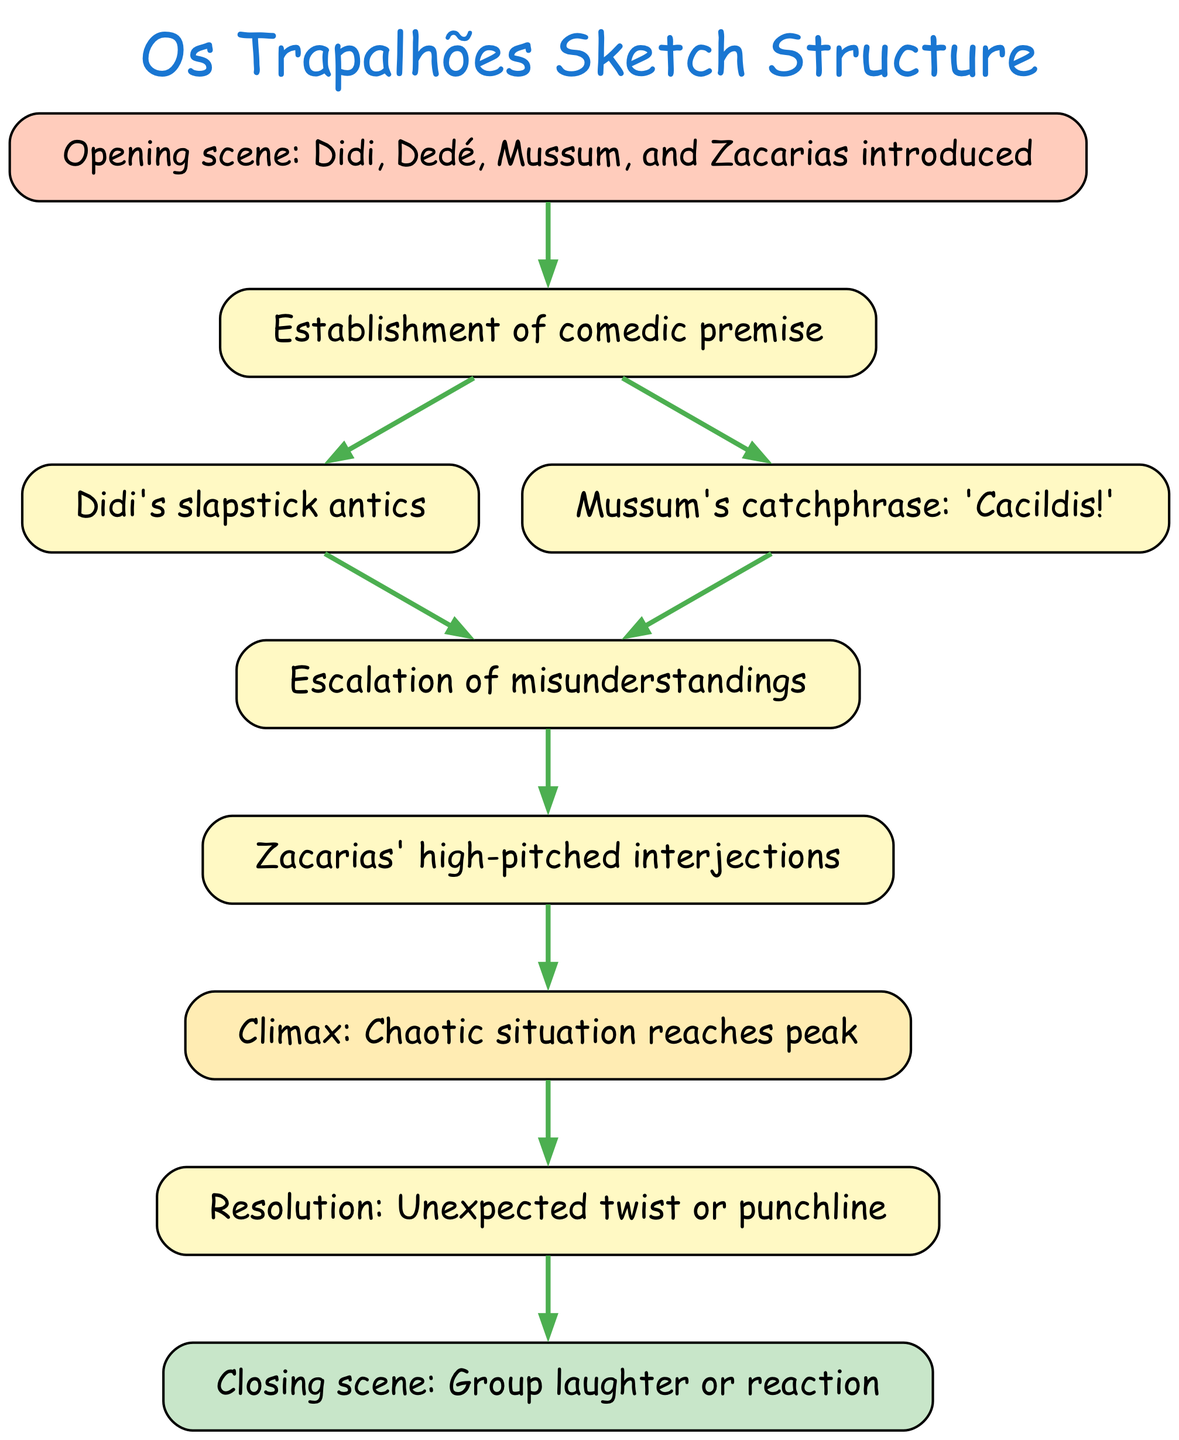What is the first scene introduced in the sketch? The diagram shows that the first scene introduced is "Didi, Dedé, Mussum, and Zacarias introduced", which is located at node 1.
Answer: Didi, Dedé, Mussum, and Zacarias introduced How many main nodes are there in the structure? The diagram lists a total of 9 main nodes that outline the steps in the sketch, from the introduction to the closing scene.
Answer: 9 What follows after the establishment of the comedic premise? The diagram indicates that after the establishment of the comedic premise (node 2), there are two branches: one leading to "Didi's slapstick antics" (node 3) and the other to "Mussum's catchphrase: 'Cacildis!'" (node 4).
Answer: Didi's slapstick antics and Mussum's catchphrase: 'Cacildis!' What is the climax of the sketch? According to the diagram, the climax is represented at node 7 as "Chaotic situation reaches peak", highlighting the most intense moment of the sketch.
Answer: Chaotic situation reaches peak What happens after the climax of the sketch? Following the climax (node 7), the next step is the "Resolution: Unexpected twist or punchline" at node 8, which indicates a transition to the conclusion of the sketch.
Answer: Resolution: Unexpected twist or punchline What type of interjections does Zacarias make? The diagram notes at node 6 that Zacarias makes "high-pitched interjections," characterizing his comedic style during the misunderstandings in the sketch.
Answer: High-pitched interjections Which character's catchphrase is highlighted in the structure? The diagram specifies at node 4 that Mussum's catchphrase "Cacildis!" is a significant element within the comedic premise, showcasing Mussum's iconic humor.
Answer: Cacildis! What color represents the opening scene in the diagram? The diagram indicates that the opening scene (node 1) is filled with the color '#FFCCBC', distinguishing it from the other elements of the sketch structure.
Answer: #FFCCBC In which node does the group laughter or reaction occur? The closing scene is noted in node 9, detailing the moment of "Group laughter or reaction," which signifies the conclusion of the comedic sketch.
Answer: Group laughter or reaction 